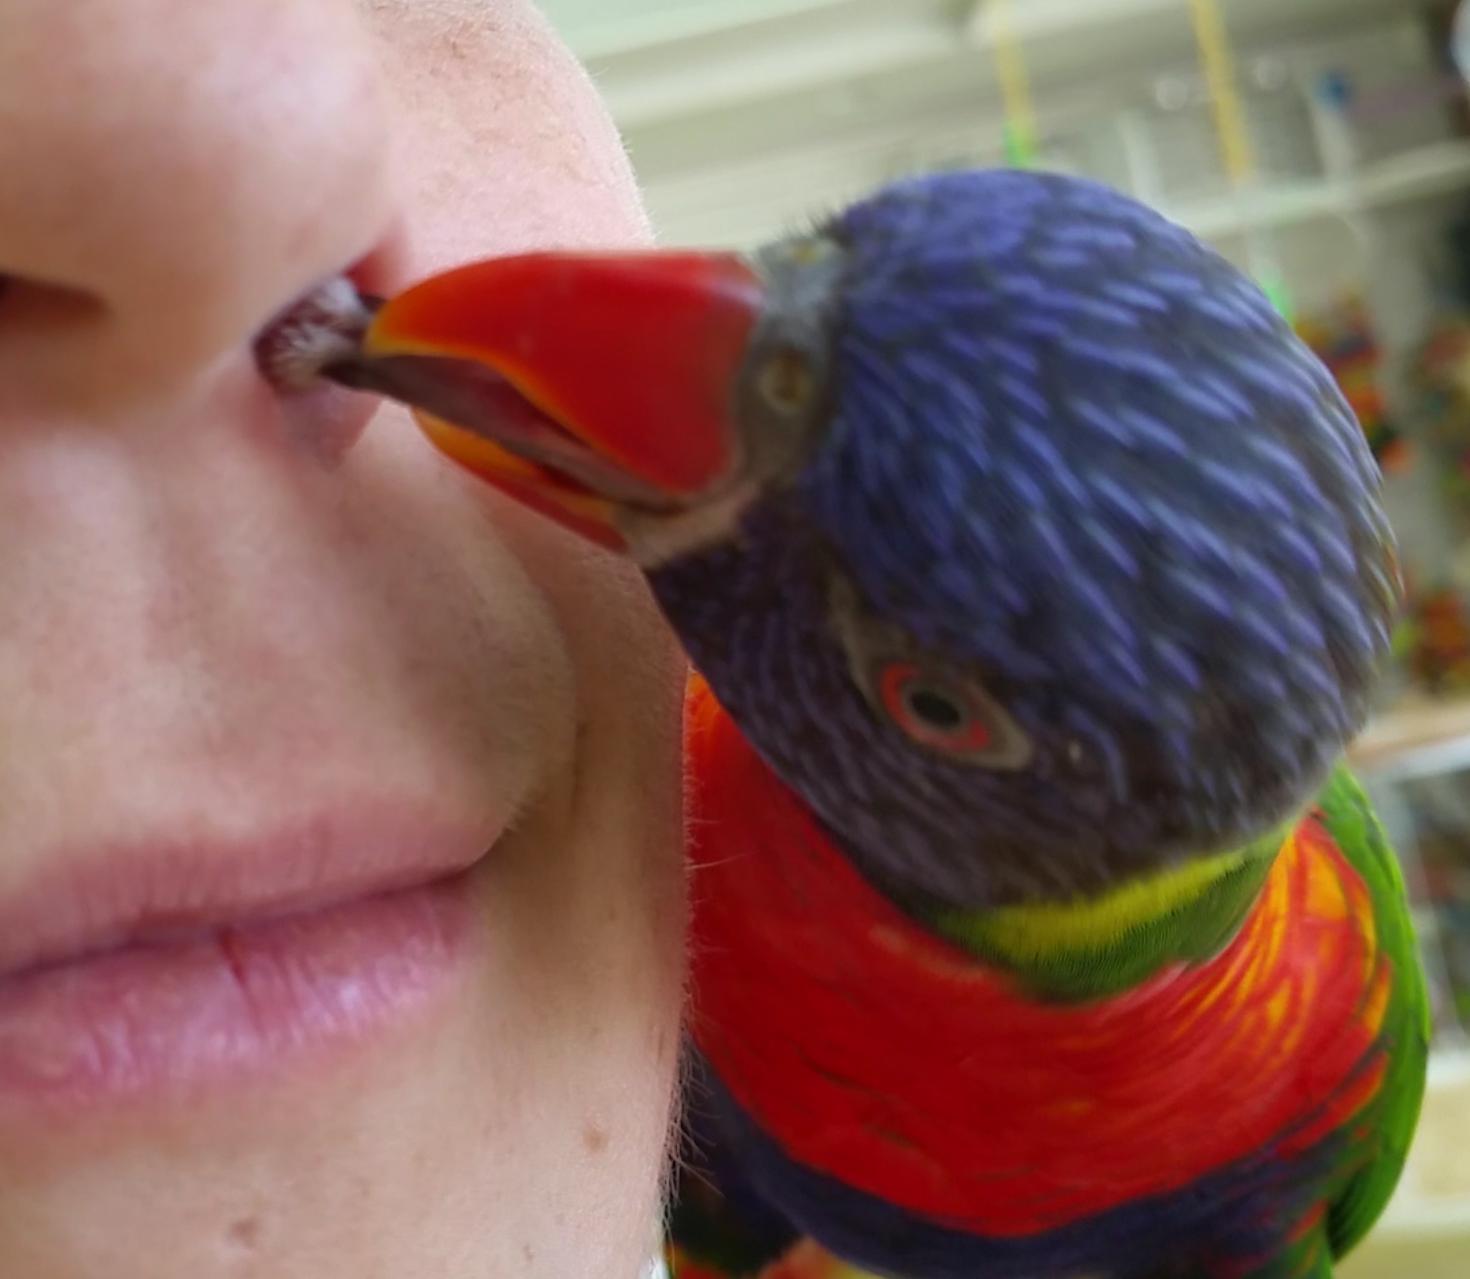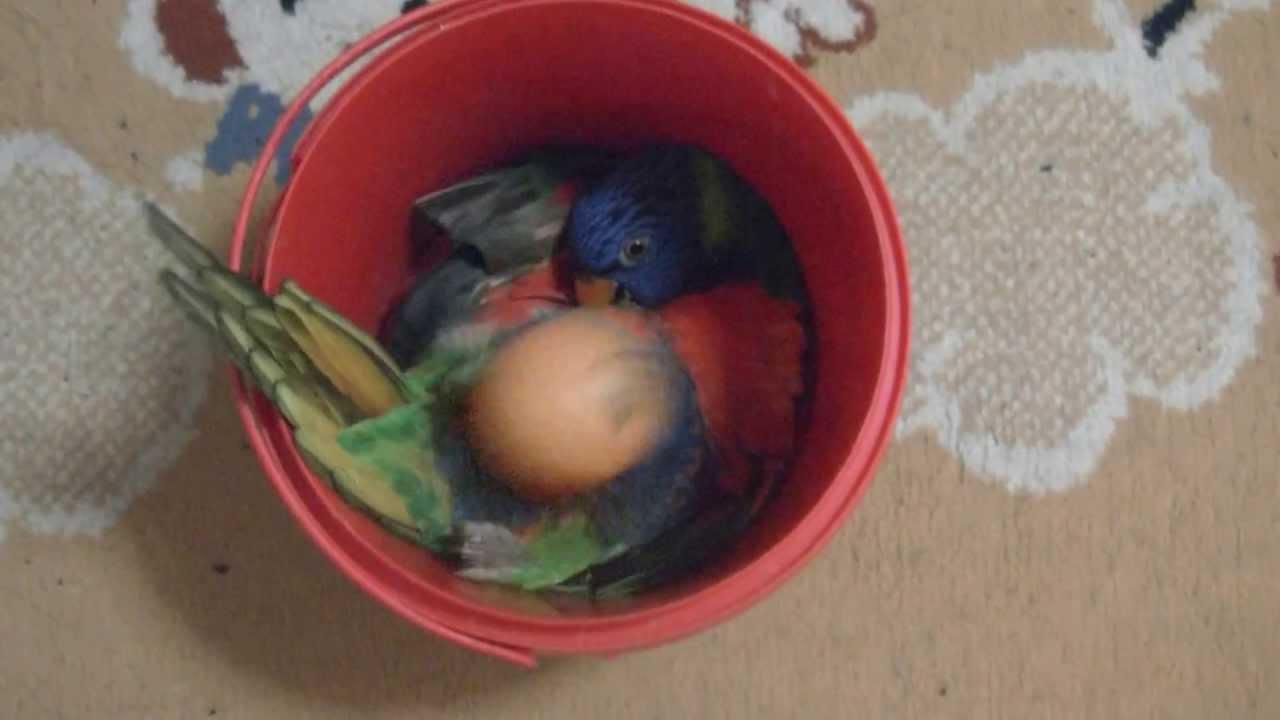The first image is the image on the left, the second image is the image on the right. Considering the images on both sides, is "Left image shows a colorful parrot near a person's head." valid? Answer yes or no. Yes. 